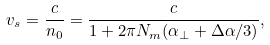Convert formula to latex. <formula><loc_0><loc_0><loc_500><loc_500>v _ { s } = \frac { c } { n _ { 0 } } = \frac { c } { 1 + 2 \pi N _ { m } ( \alpha _ { \perp } + \Delta \alpha / 3 ) } ,</formula> 